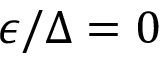<formula> <loc_0><loc_0><loc_500><loc_500>\epsilon / \Delta = 0</formula> 